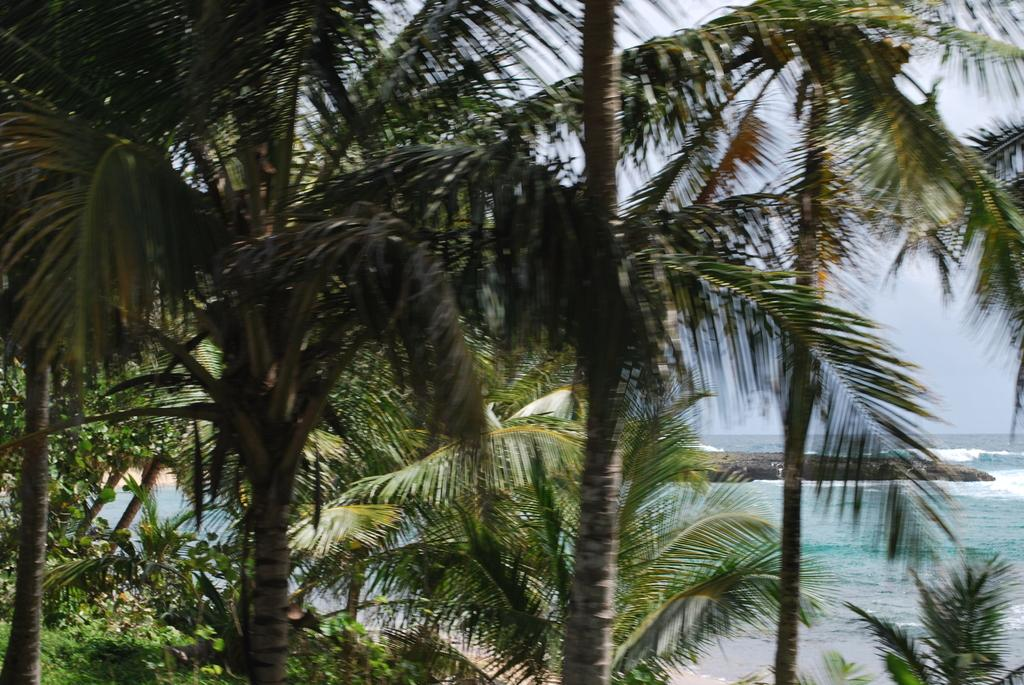What type of vegetation is on the left side of the image? There are huge trees on the left side of the image. What natural feature is on the right side of the image? There is a river on the right side of the image. What can be seen in the background of the image? The sky is visible in the background of the image. What is the title of the book that is being read by the person in the image? There is no person or book present in the image. How many balls are visible in the image? There are no balls present in the image. 